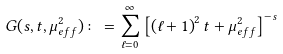<formula> <loc_0><loc_0><loc_500><loc_500>G ( s , t , \mu _ { e f f } ^ { 2 } ) \colon = \sum _ { \ell = 0 } ^ { \infty } \left [ \left ( \ell + 1 \right ) ^ { 2 } t + \mu _ { e f f } ^ { 2 } \right ] ^ { - s }</formula> 